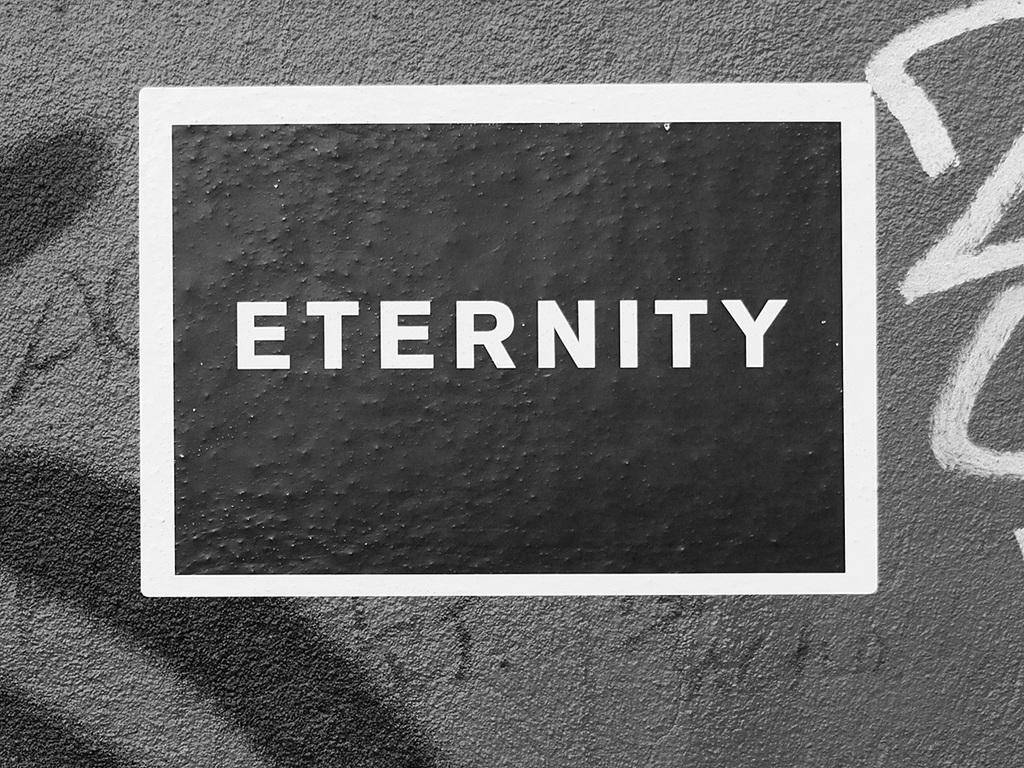What do the block letters say?
Your response must be concise. Eternity. 